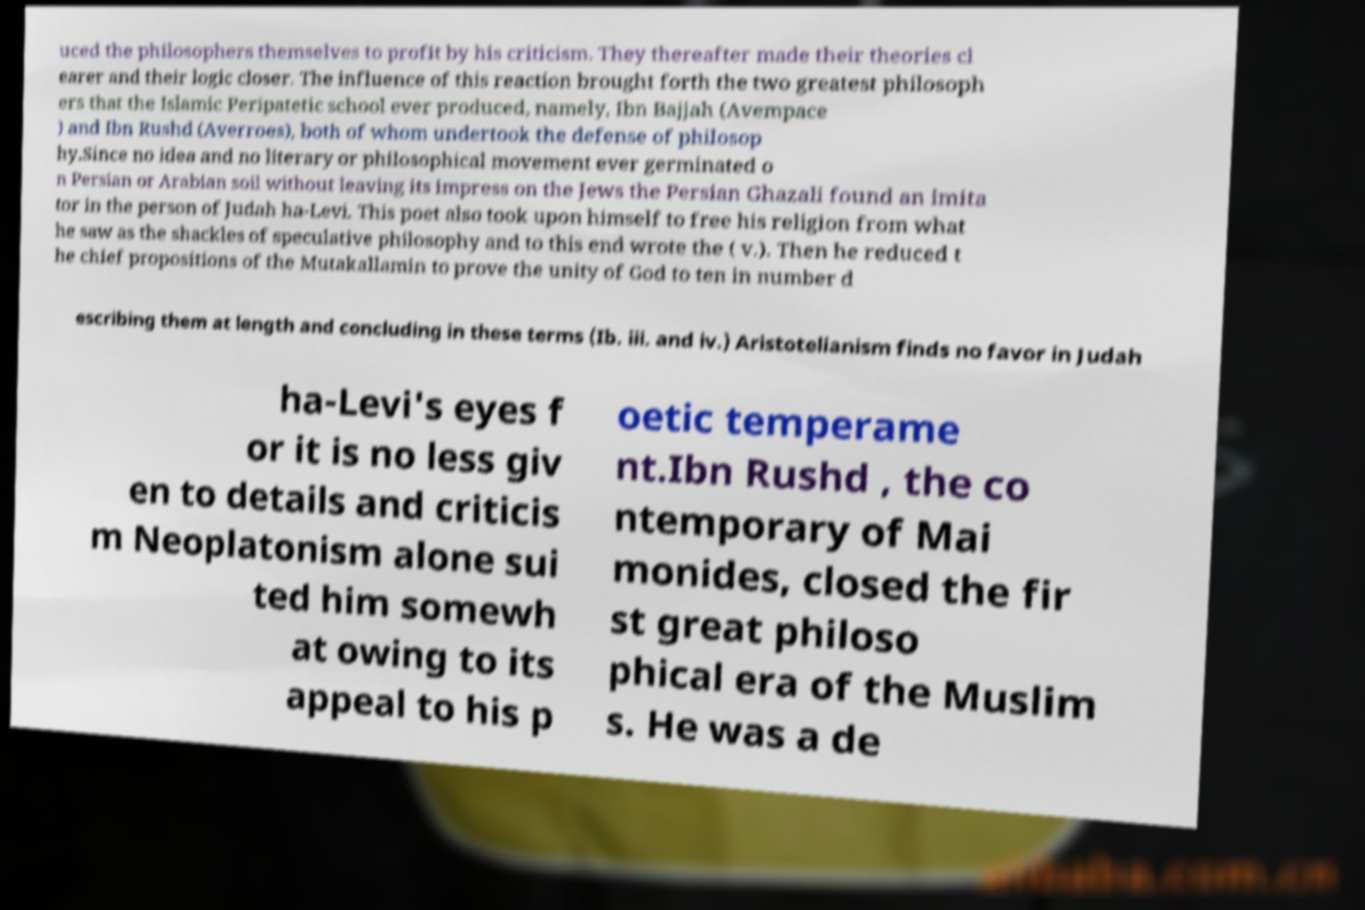Could you extract and type out the text from this image? uced the philosophers themselves to profit by his criticism. They thereafter made their theories cl earer and their logic closer. The influence of this reaction brought forth the two greatest philosoph ers that the Islamic Peripatetic school ever produced, namely, Ibn Bajjah (Avempace ) and Ibn Rushd (Averroes), both of whom undertook the defense of philosop hy.Since no idea and no literary or philosophical movement ever germinated o n Persian or Arabian soil without leaving its impress on the Jews the Persian Ghazali found an imita tor in the person of Judah ha-Levi. This poet also took upon himself to free his religion from what he saw as the shackles of speculative philosophy and to this end wrote the ( v.). Then he reduced t he chief propositions of the Mutakallamin to prove the unity of God to ten in number d escribing them at length and concluding in these terms (Ib. iii. and iv.) Aristotelianism finds no favor in Judah ha-Levi's eyes f or it is no less giv en to details and criticis m Neoplatonism alone sui ted him somewh at owing to its appeal to his p oetic temperame nt.Ibn Rushd , the co ntemporary of Mai monides, closed the fir st great philoso phical era of the Muslim s. He was a de 